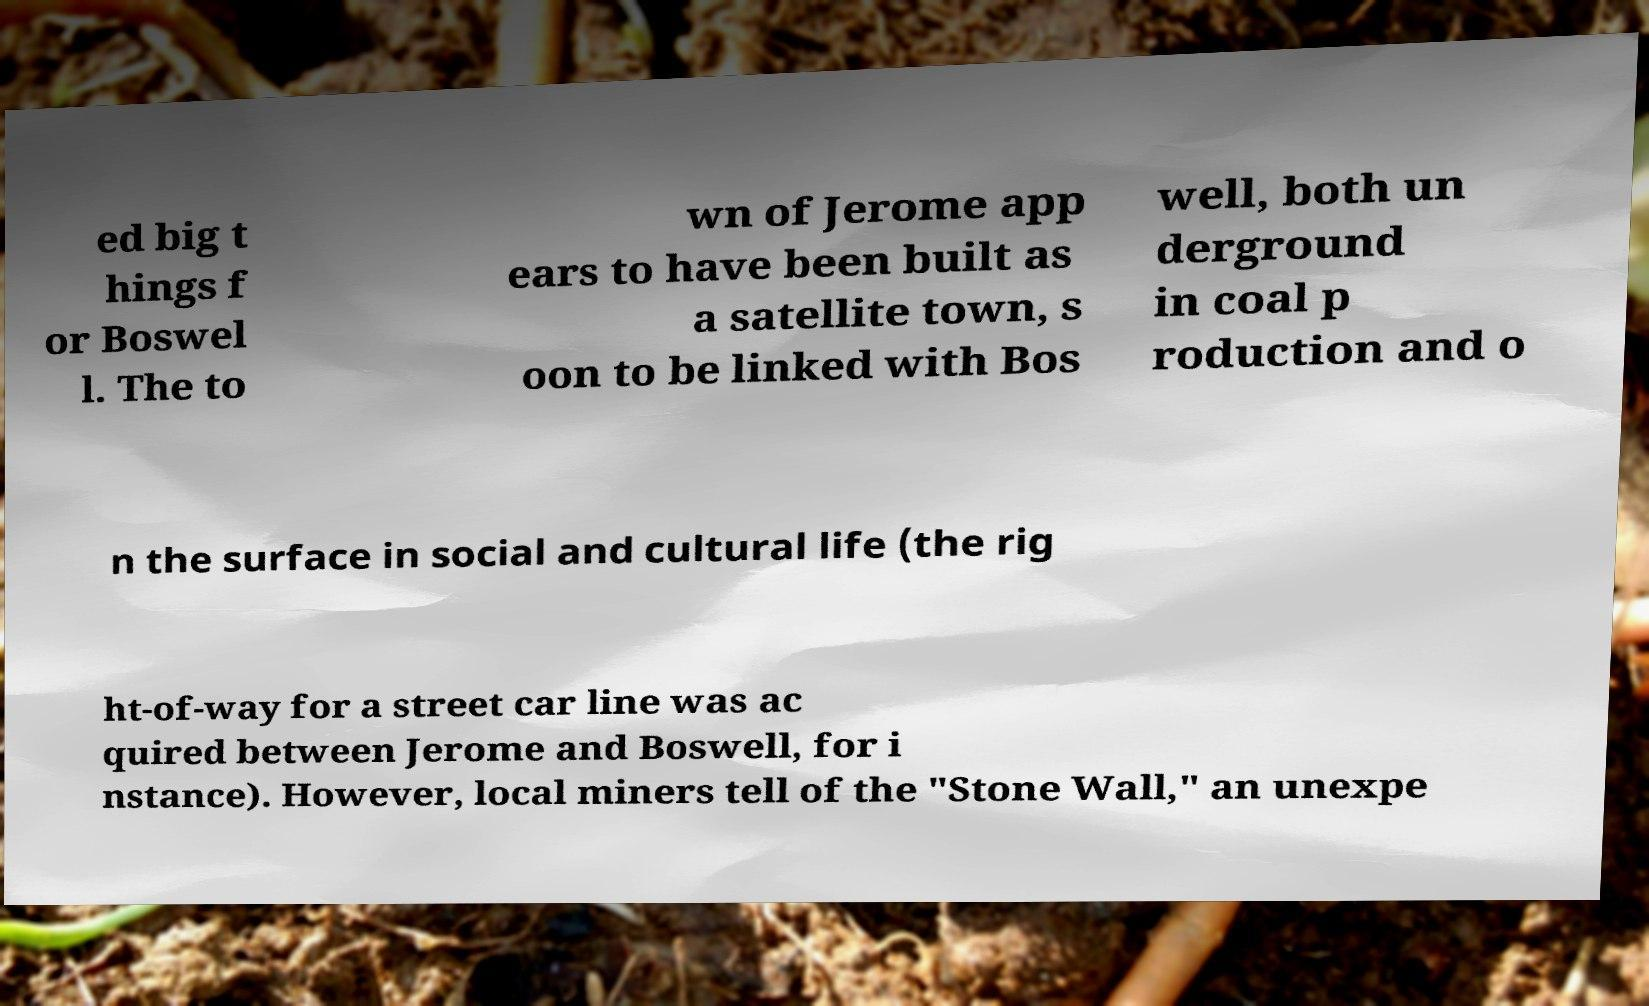Please read and relay the text visible in this image. What does it say? ed big t hings f or Boswel l. The to wn of Jerome app ears to have been built as a satellite town, s oon to be linked with Bos well, both un derground in coal p roduction and o n the surface in social and cultural life (the rig ht-of-way for a street car line was ac quired between Jerome and Boswell, for i nstance). However, local miners tell of the "Stone Wall," an unexpe 